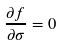<formula> <loc_0><loc_0><loc_500><loc_500>\frac { \partial f } { \partial \sigma } = 0</formula> 